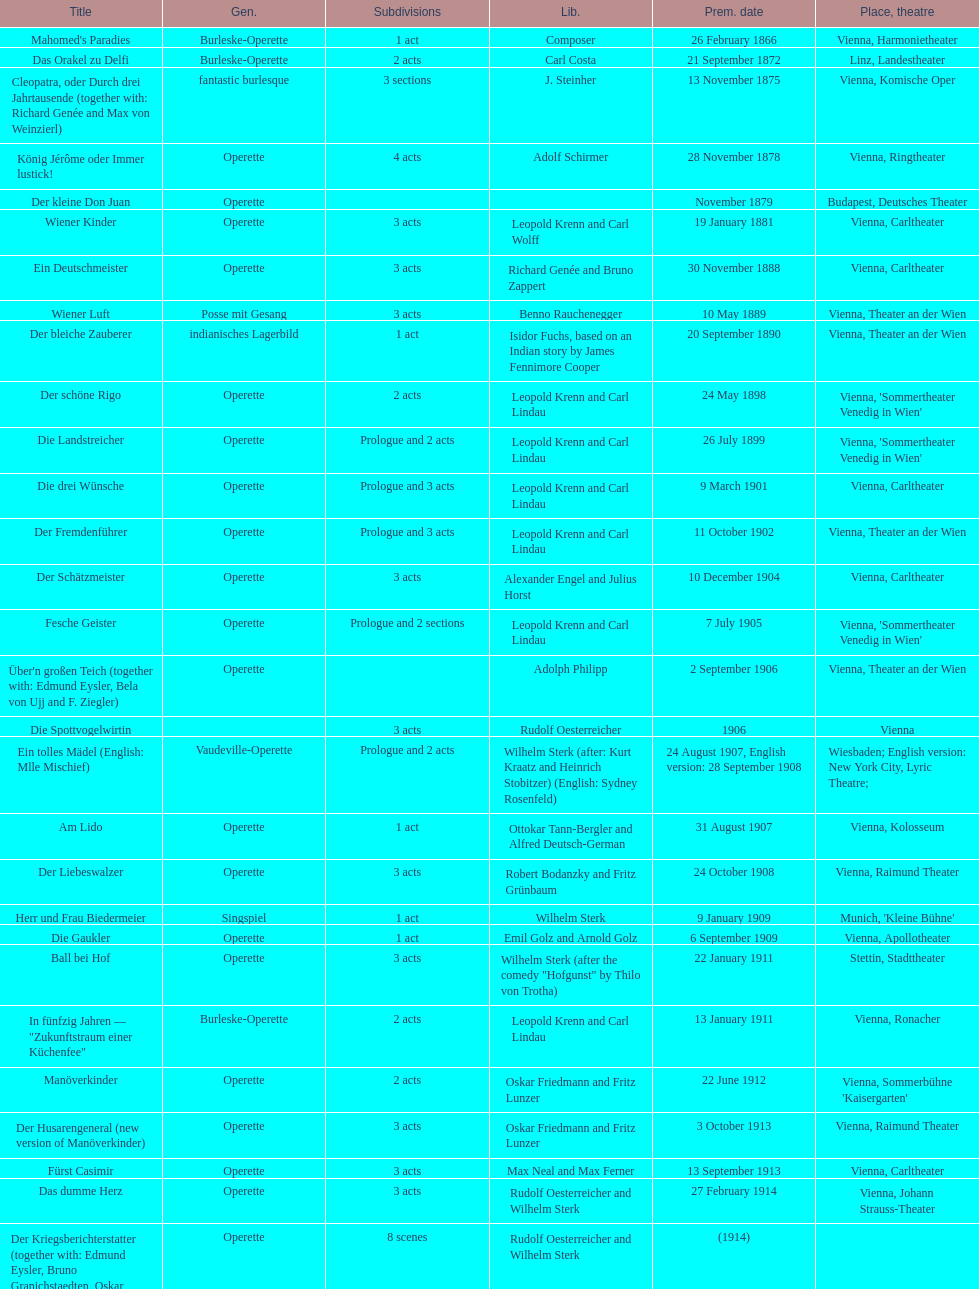Which year did he release his last operetta? 1930. 